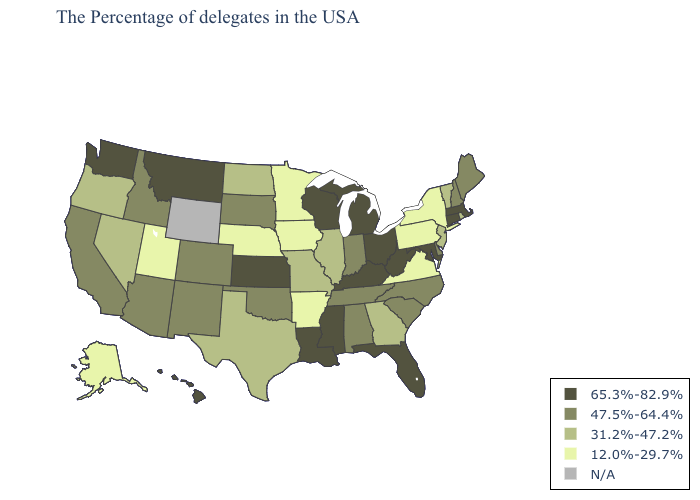Name the states that have a value in the range N/A?
Concise answer only. Wyoming. What is the lowest value in the South?
Answer briefly. 12.0%-29.7%. Name the states that have a value in the range N/A?
Short answer required. Wyoming. Name the states that have a value in the range 47.5%-64.4%?
Keep it brief. Maine, New Hampshire, Delaware, North Carolina, South Carolina, Indiana, Alabama, Tennessee, Oklahoma, South Dakota, Colorado, New Mexico, Arizona, Idaho, California. Name the states that have a value in the range 65.3%-82.9%?
Short answer required. Massachusetts, Connecticut, Maryland, West Virginia, Ohio, Florida, Michigan, Kentucky, Wisconsin, Mississippi, Louisiana, Kansas, Montana, Washington, Hawaii. Name the states that have a value in the range 65.3%-82.9%?
Give a very brief answer. Massachusetts, Connecticut, Maryland, West Virginia, Ohio, Florida, Michigan, Kentucky, Wisconsin, Mississippi, Louisiana, Kansas, Montana, Washington, Hawaii. Does New York have the lowest value in the USA?
Short answer required. Yes. Is the legend a continuous bar?
Give a very brief answer. No. Name the states that have a value in the range N/A?
Concise answer only. Wyoming. Among the states that border Colorado , does Kansas have the highest value?
Write a very short answer. Yes. What is the value of Tennessee?
Quick response, please. 47.5%-64.4%. Is the legend a continuous bar?
Be succinct. No. Among the states that border Wisconsin , does Iowa have the lowest value?
Keep it brief. Yes. Does the map have missing data?
Write a very short answer. Yes. Among the states that border Washington , which have the lowest value?
Be succinct. Oregon. 